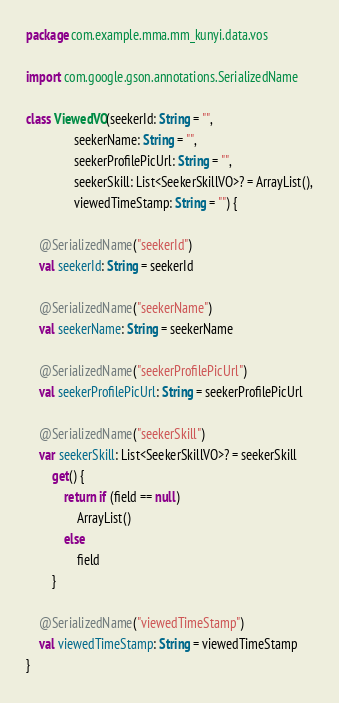Convert code to text. <code><loc_0><loc_0><loc_500><loc_500><_Kotlin_>package com.example.mma.mm_kunyi.data.vos

import com.google.gson.annotations.SerializedName

class ViewedVO(seekerId: String = "",
               seekerName: String = "",
               seekerProfilePicUrl: String = "",
               seekerSkill: List<SeekerSkillVO>? = ArrayList(),
               viewedTimeStamp: String = "") {

    @SerializedName("seekerId")
    val seekerId: String = seekerId

    @SerializedName("seekerName")
    val seekerName: String = seekerName

    @SerializedName("seekerProfilePicUrl")
    val seekerProfilePicUrl: String = seekerProfilePicUrl

    @SerializedName("seekerSkill")
    var seekerSkill: List<SeekerSkillVO>? = seekerSkill
        get() {
            return if (field == null)
                ArrayList()
            else
                field
        }

    @SerializedName("viewedTimeStamp")
    val viewedTimeStamp: String = viewedTimeStamp
}</code> 